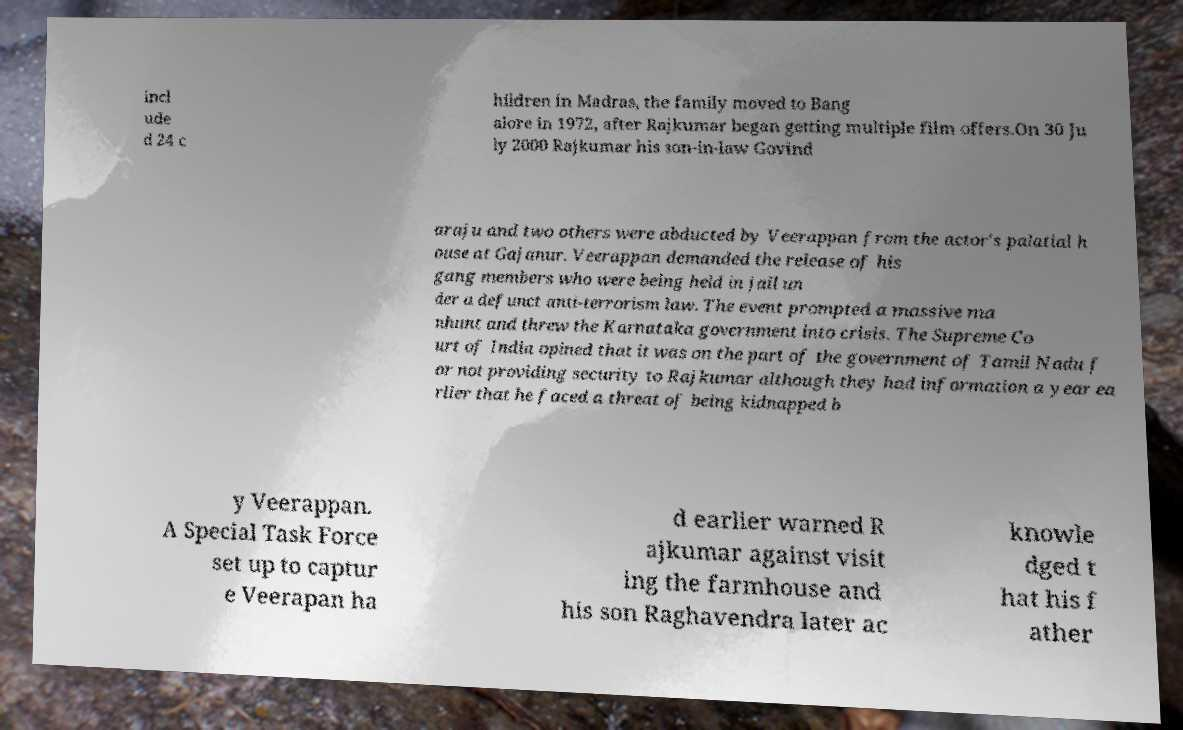I need the written content from this picture converted into text. Can you do that? incl ude d 24 c hildren in Madras, the family moved to Bang alore in 1972, after Rajkumar began getting multiple film offers.On 30 Ju ly 2000 Rajkumar his son-in-law Govind araju and two others were abducted by Veerappan from the actor's palatial h ouse at Gajanur. Veerappan demanded the release of his gang members who were being held in jail un der a defunct anti-terrorism law. The event prompted a massive ma nhunt and threw the Karnataka government into crisis. The Supreme Co urt of India opined that it was on the part of the government of Tamil Nadu f or not providing security to Rajkumar although they had information a year ea rlier that he faced a threat of being kidnapped b y Veerappan. A Special Task Force set up to captur e Veerapan ha d earlier warned R ajkumar against visit ing the farmhouse and his son Raghavendra later ac knowle dged t hat his f ather 